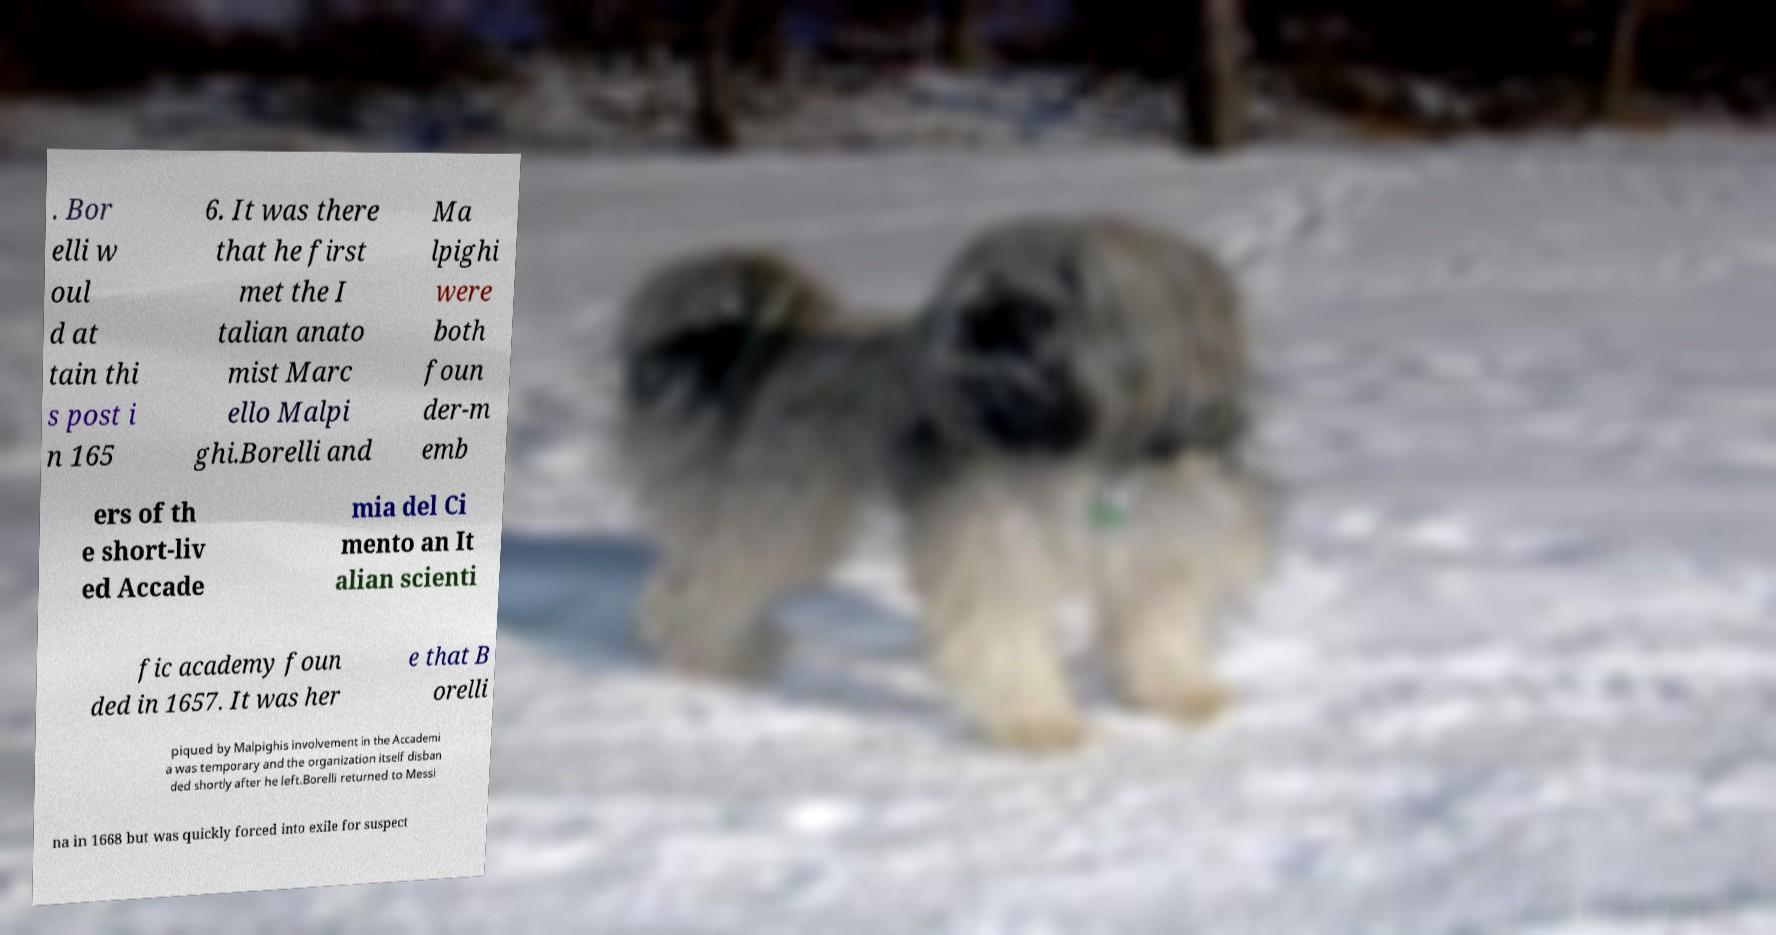There's text embedded in this image that I need extracted. Can you transcribe it verbatim? . Bor elli w oul d at tain thi s post i n 165 6. It was there that he first met the I talian anato mist Marc ello Malpi ghi.Borelli and Ma lpighi were both foun der-m emb ers of th e short-liv ed Accade mia del Ci mento an It alian scienti fic academy foun ded in 1657. It was her e that B orelli piqued by Malpighis involvement in the Accademi a was temporary and the organization itself disban ded shortly after he left.Borelli returned to Messi na in 1668 but was quickly forced into exile for suspect 